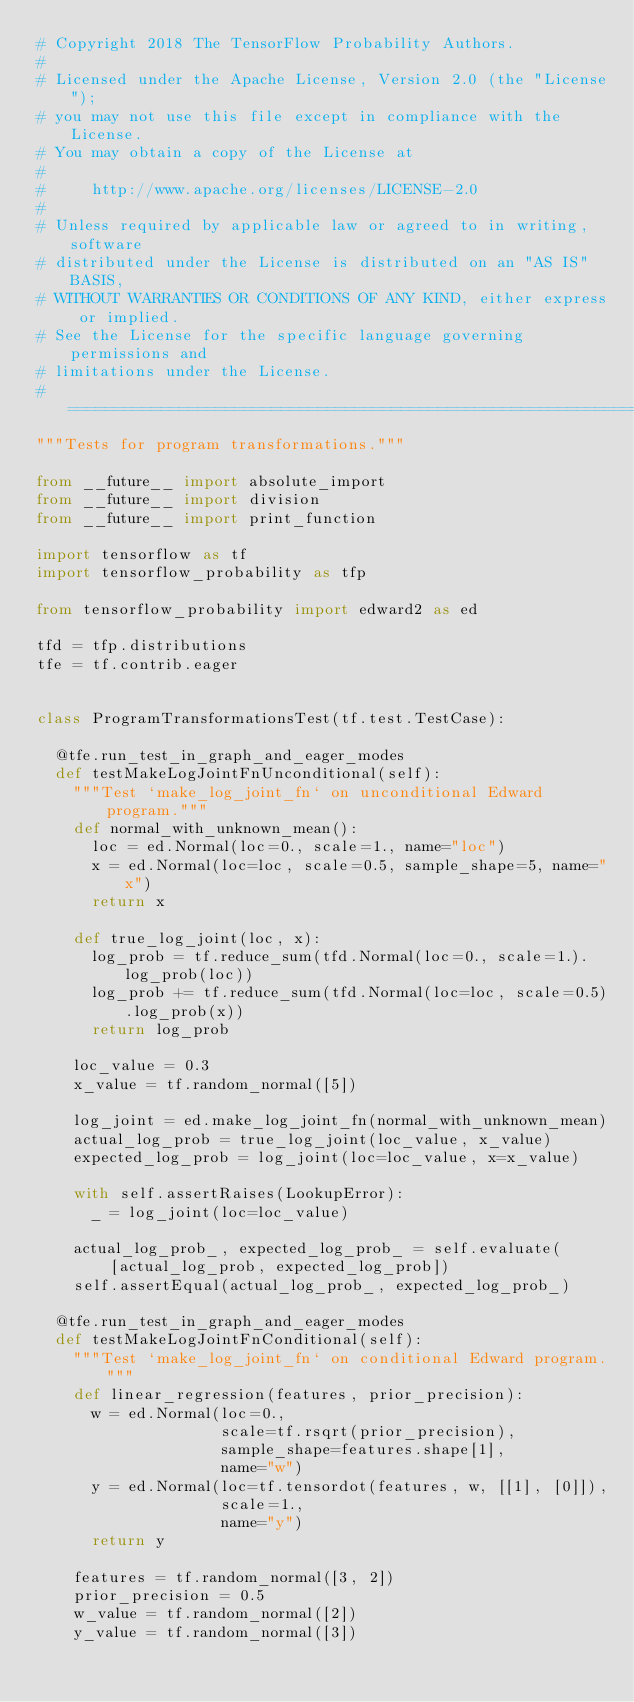<code> <loc_0><loc_0><loc_500><loc_500><_Python_># Copyright 2018 The TensorFlow Probability Authors.
#
# Licensed under the Apache License, Version 2.0 (the "License");
# you may not use this file except in compliance with the License.
# You may obtain a copy of the License at
#
#     http://www.apache.org/licenses/LICENSE-2.0
#
# Unless required by applicable law or agreed to in writing, software
# distributed under the License is distributed on an "AS IS" BASIS,
# WITHOUT WARRANTIES OR CONDITIONS OF ANY KIND, either express or implied.
# See the License for the specific language governing permissions and
# limitations under the License.
# ============================================================================
"""Tests for program transformations."""

from __future__ import absolute_import
from __future__ import division
from __future__ import print_function

import tensorflow as tf
import tensorflow_probability as tfp

from tensorflow_probability import edward2 as ed

tfd = tfp.distributions
tfe = tf.contrib.eager


class ProgramTransformationsTest(tf.test.TestCase):

  @tfe.run_test_in_graph_and_eager_modes
  def testMakeLogJointFnUnconditional(self):
    """Test `make_log_joint_fn` on unconditional Edward program."""
    def normal_with_unknown_mean():
      loc = ed.Normal(loc=0., scale=1., name="loc")
      x = ed.Normal(loc=loc, scale=0.5, sample_shape=5, name="x")
      return x

    def true_log_joint(loc, x):
      log_prob = tf.reduce_sum(tfd.Normal(loc=0., scale=1.).log_prob(loc))
      log_prob += tf.reduce_sum(tfd.Normal(loc=loc, scale=0.5).log_prob(x))
      return log_prob

    loc_value = 0.3
    x_value = tf.random_normal([5])

    log_joint = ed.make_log_joint_fn(normal_with_unknown_mean)
    actual_log_prob = true_log_joint(loc_value, x_value)
    expected_log_prob = log_joint(loc=loc_value, x=x_value)

    with self.assertRaises(LookupError):
      _ = log_joint(loc=loc_value)

    actual_log_prob_, expected_log_prob_ = self.evaluate(
        [actual_log_prob, expected_log_prob])
    self.assertEqual(actual_log_prob_, expected_log_prob_)

  @tfe.run_test_in_graph_and_eager_modes
  def testMakeLogJointFnConditional(self):
    """Test `make_log_joint_fn` on conditional Edward program."""
    def linear_regression(features, prior_precision):
      w = ed.Normal(loc=0.,
                    scale=tf.rsqrt(prior_precision),
                    sample_shape=features.shape[1],
                    name="w")
      y = ed.Normal(loc=tf.tensordot(features, w, [[1], [0]]),
                    scale=1.,
                    name="y")
      return y

    features = tf.random_normal([3, 2])
    prior_precision = 0.5
    w_value = tf.random_normal([2])
    y_value = tf.random_normal([3])
</code> 